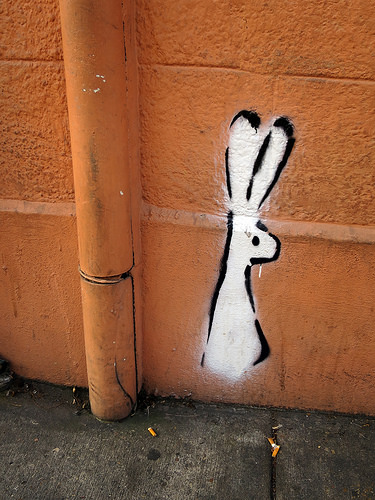<image>
Is the bunny nose in front of the pipe? No. The bunny nose is not in front of the pipe. The spatial positioning shows a different relationship between these objects. 